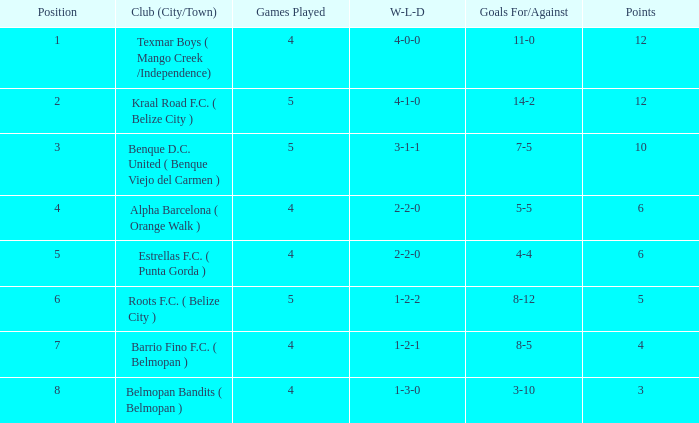Who is the the club (city/town) with goals for/against being 14-2 Kraal Road F.C. ( Belize City ). 